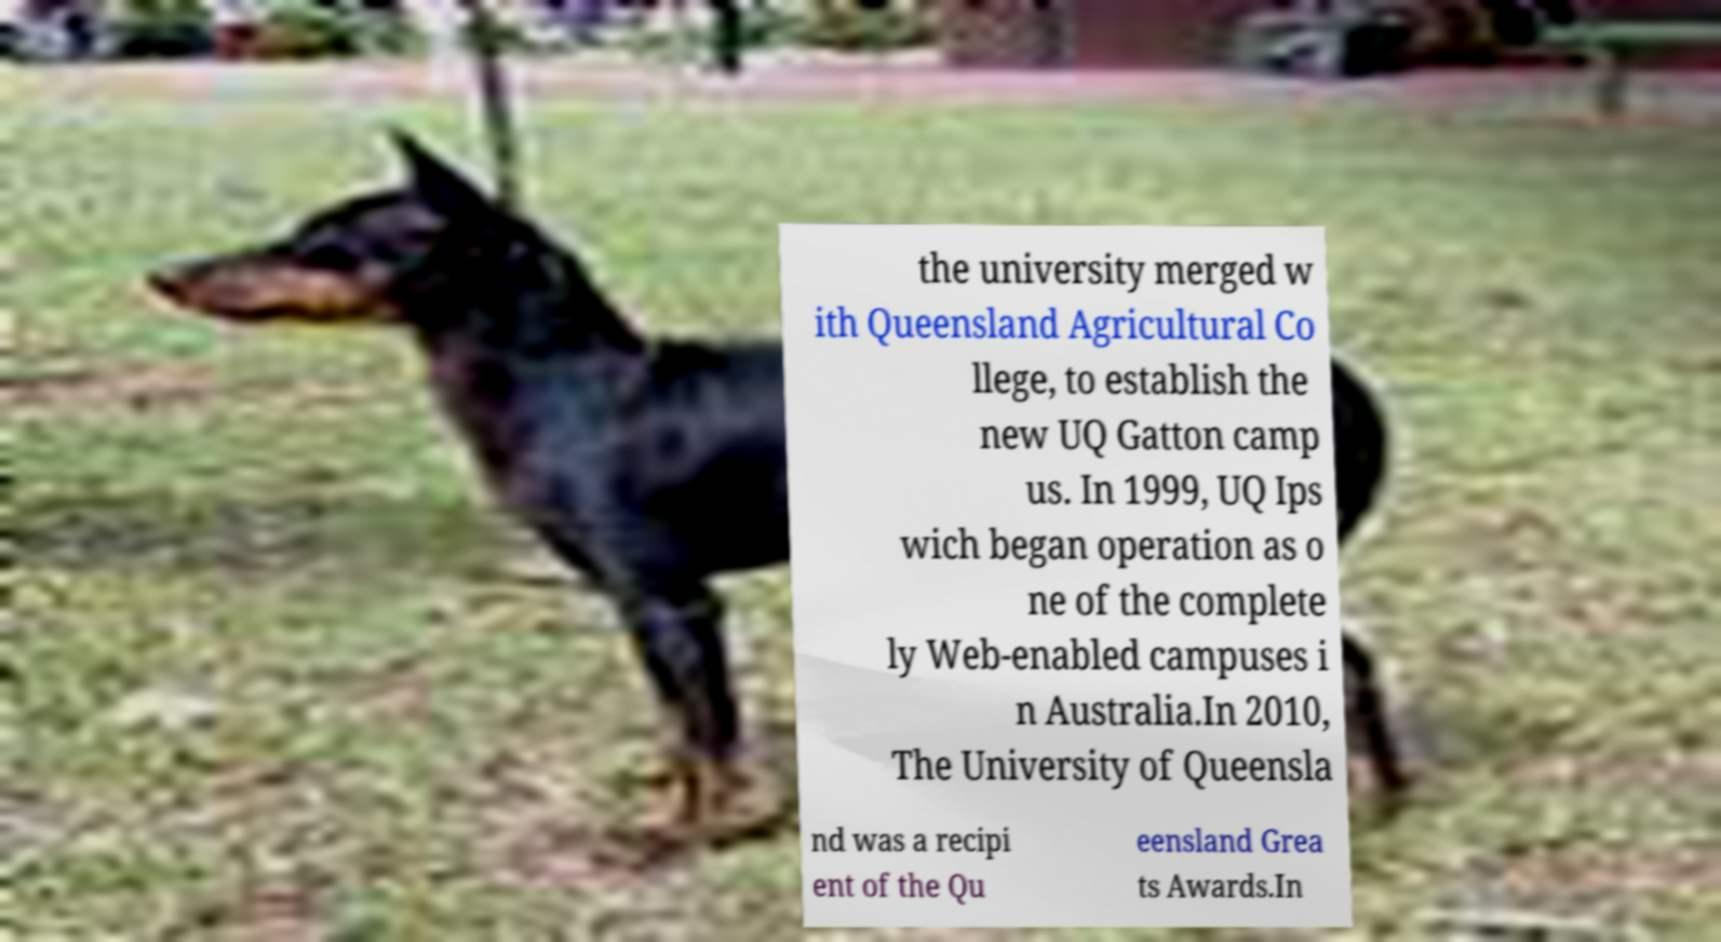Could you assist in decoding the text presented in this image and type it out clearly? the university merged w ith Queensland Agricultural Co llege, to establish the new UQ Gatton camp us. In 1999, UQ Ips wich began operation as o ne of the complete ly Web-enabled campuses i n Australia.In 2010, The University of Queensla nd was a recipi ent of the Qu eensland Grea ts Awards.In 